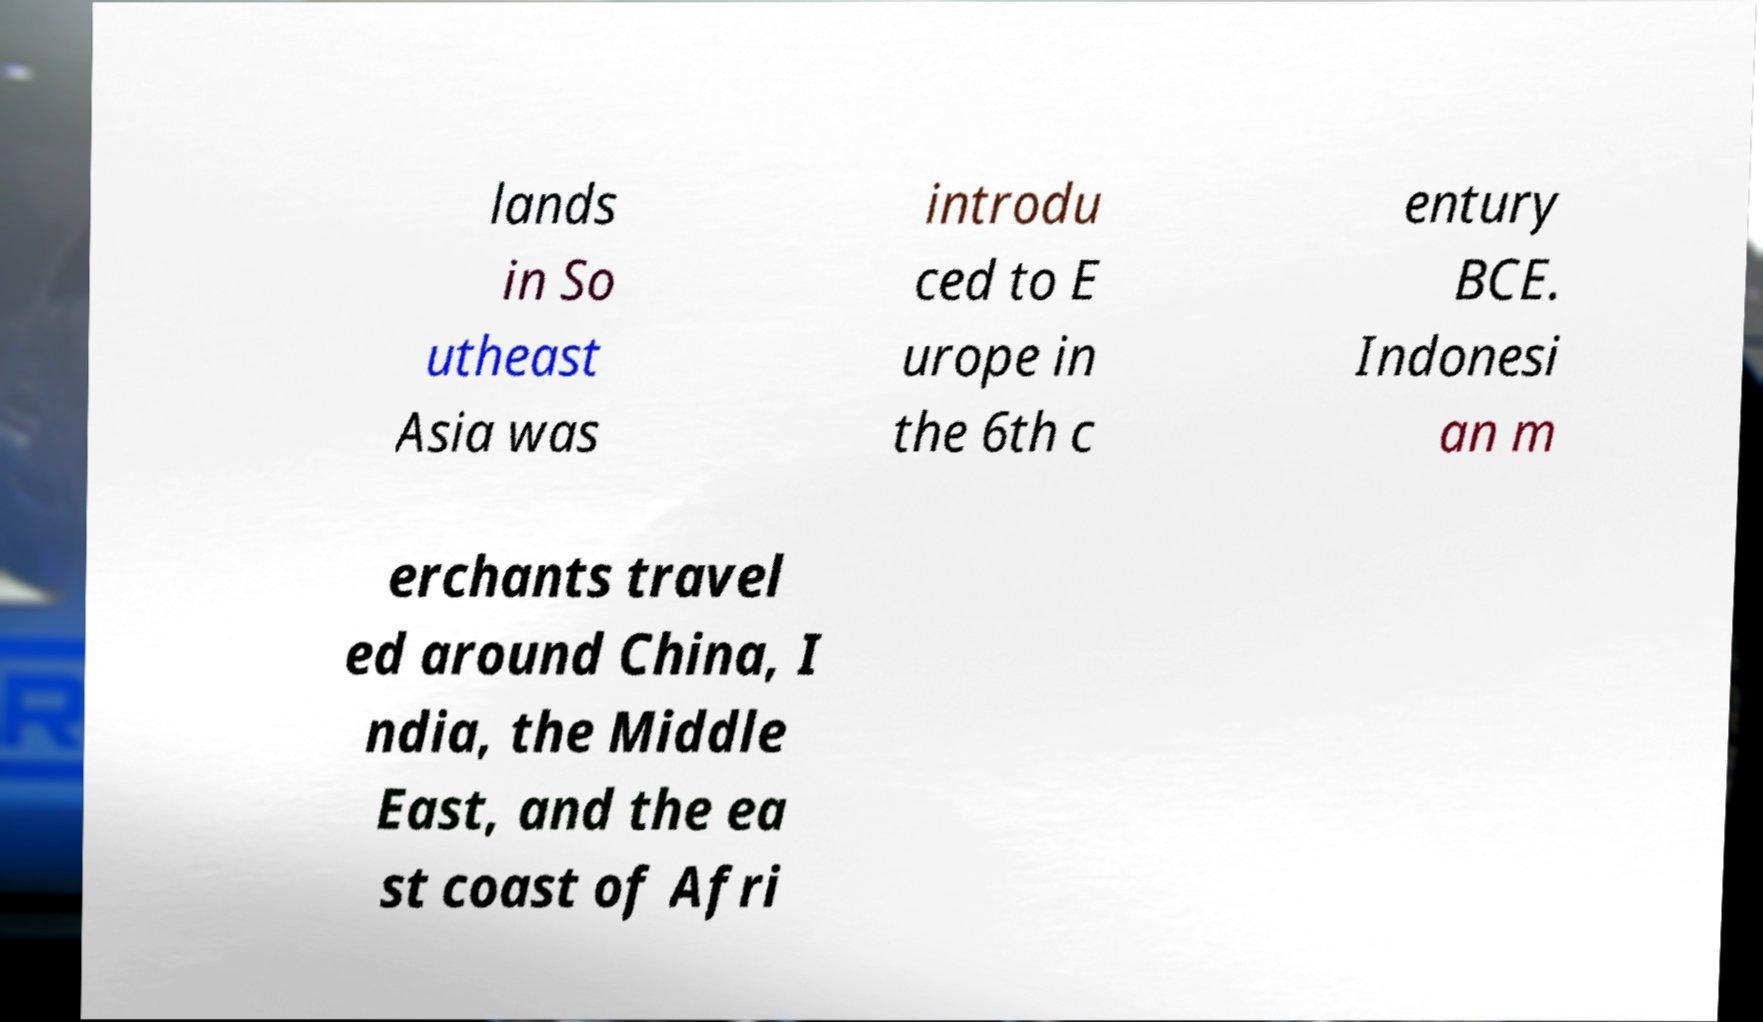I need the written content from this picture converted into text. Can you do that? lands in So utheast Asia was introdu ced to E urope in the 6th c entury BCE. Indonesi an m erchants travel ed around China, I ndia, the Middle East, and the ea st coast of Afri 